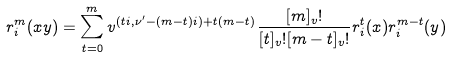Convert formula to latex. <formula><loc_0><loc_0><loc_500><loc_500>{ r ^ { m } _ { i } } ( x y ) = \sum _ { t = 0 } ^ { m } v ^ { ( t i , \nu ^ { \prime } - ( m - t ) i ) + t ( m - t ) } \frac { [ m ] _ { v } ! } { [ t ] _ { v } ! [ m - t ] _ { v } ! } { r _ { i } ^ { t } } ( x ) { r _ { i } ^ { m - t } } ( y )</formula> 